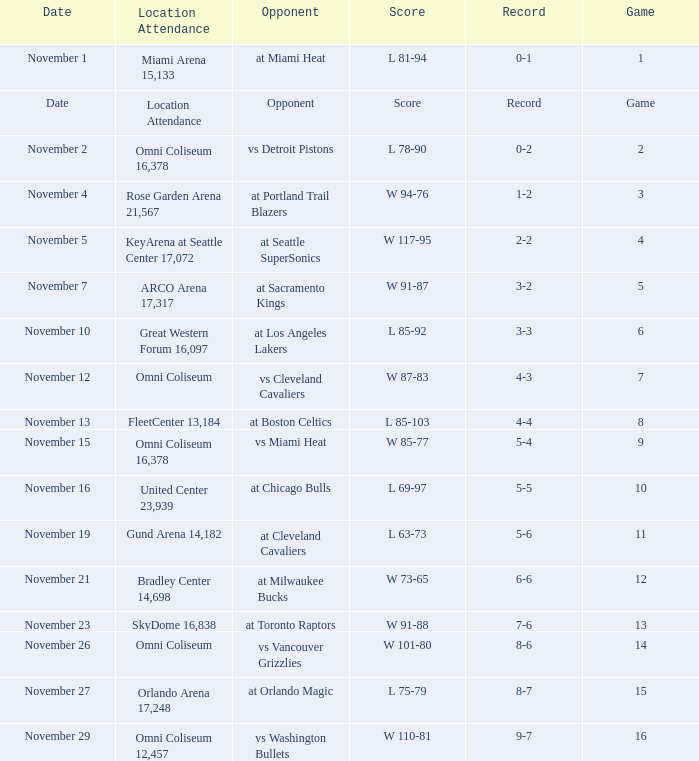I'm looking to parse the entire table for insights. Could you assist me with that? {'header': ['Date', 'Location Attendance', 'Opponent', 'Score', 'Record', 'Game'], 'rows': [['November 1', 'Miami Arena 15,133', 'at Miami Heat', 'L 81-94', '0-1', '1'], ['Date', 'Location Attendance', 'Opponent', 'Score', 'Record', 'Game'], ['November 2', 'Omni Coliseum 16,378', 'vs Detroit Pistons', 'L 78-90', '0-2', '2'], ['November 4', 'Rose Garden Arena 21,567', 'at Portland Trail Blazers', 'W 94-76', '1-2', '3'], ['November 5', 'KeyArena at Seattle Center 17,072', 'at Seattle SuperSonics', 'W 117-95', '2-2', '4'], ['November 7', 'ARCO Arena 17,317', 'at Sacramento Kings', 'W 91-87', '3-2', '5'], ['November 10', 'Great Western Forum 16,097', 'at Los Angeles Lakers', 'L 85-92', '3-3', '6'], ['November 12', 'Omni Coliseum', 'vs Cleveland Cavaliers', 'W 87-83', '4-3', '7'], ['November 13', 'FleetCenter 13,184', 'at Boston Celtics', 'L 85-103', '4-4', '8'], ['November 15', 'Omni Coliseum 16,378', 'vs Miami Heat', 'W 85-77', '5-4', '9'], ['November 16', 'United Center 23,939', 'at Chicago Bulls', 'L 69-97', '5-5', '10'], ['November 19', 'Gund Arena 14,182', 'at Cleveland Cavaliers', 'L 63-73', '5-6', '11'], ['November 21', 'Bradley Center 14,698', 'at Milwaukee Bucks', 'W 73-65', '6-6', '12'], ['November 23', 'SkyDome 16,838', 'at Toronto Raptors', 'W 91-88', '7-6', '13'], ['November 26', 'Omni Coliseum', 'vs Vancouver Grizzlies', 'W 101-80', '8-6', '14'], ['November 27', 'Orlando Arena 17,248', 'at Orlando Magic', 'L 75-79', '8-7', '15'], ['November 29', 'Omni Coliseum 12,457', 'vs Washington Bullets', 'W 110-81', '9-7', '16']]} On what date was game 3? November 4. 